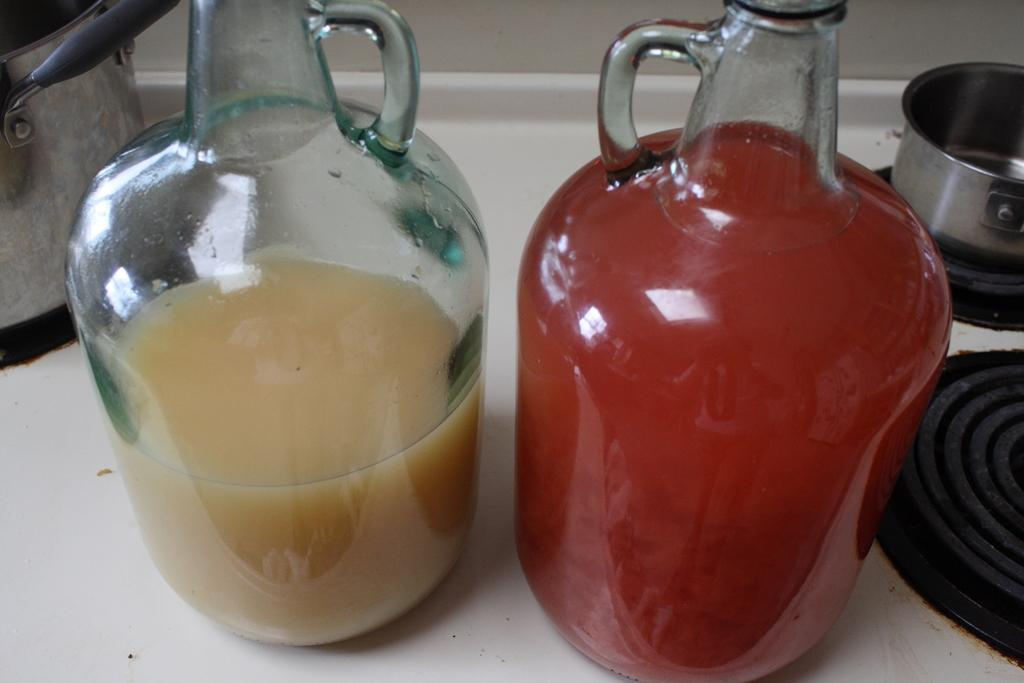What can be seen in the image related to beverages? There are two jars of juice in the image. Where are the jars of juice located? The jars of juice are on a gas stove. What else is present on the gas stove in the image? There are vessels on the gas stove in the image. What type of feather can be seen floating in the air in the image? There is no feather present in the image; it only features jars of juice and vessels on a gas stove. 